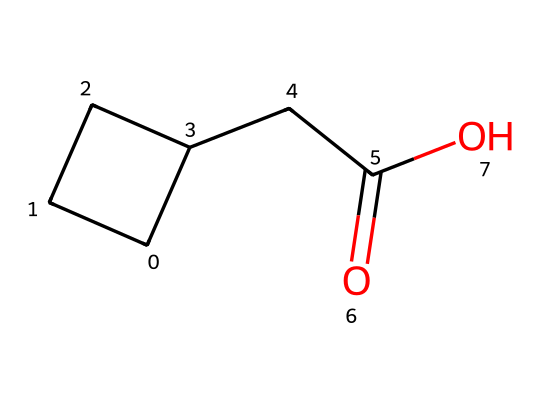How many carbon atoms are in this compound? By examining the provided SMILES representation, we can count the carbon atoms indicated by the letter "C". There are 6 carbon atoms in total: 4 in the cyclobutane ring and 2 in the side chain (the propionic acid group).
Answer: 6 What functional group is present in this molecule? The molecule has a carboxylic acid functional group, which is identified by the presence of the -COOH group at the end of the structure. This is confirmed by the "C(=O)O" portion of the SMILES.
Answer: carboxylic acid What is the number of hydrogen atoms in this compound? To find the number of hydrogen atoms, we can apply the general formula CnH2n for cycloalkanes, which is then adjusted for the carboxylic acid part. Here, n=6 gives us 2(6)=12 hydrogens, but since there is also a carboxylic acid, one hydrogen is replaced and we have a total of 10.
Answer: 10 Which part of this compound indicates it's a cycloalkane? The cyclobutane part of the structure is represented by the C1CCC1 notation in the SMILES. This indicates a ring structure (cyclo) comprised of four carbon atoms arranged in a closed loop, classifying it as a cycloalkane.
Answer: C1CCC1 What is the expected state of this compound at room temperature? Cycloalkanes, depending on their size, are generally liquids or gases at room temperature. Given that this is a small cycloalkane with a carboxylic acid, it is likely to be a liquid, corroborated by its low molecular weight and the presence of the -COOH group, which increases volatility.
Answer: liquid Is this compound likely to be soluble in water? The presence of the carboxylic acid (-COOH) suggests the molecule has polar characteristics due to hydrogen bonding potential, thus it is likely to be soluble in water compared to non-polar hydrocarbons.
Answer: yes 